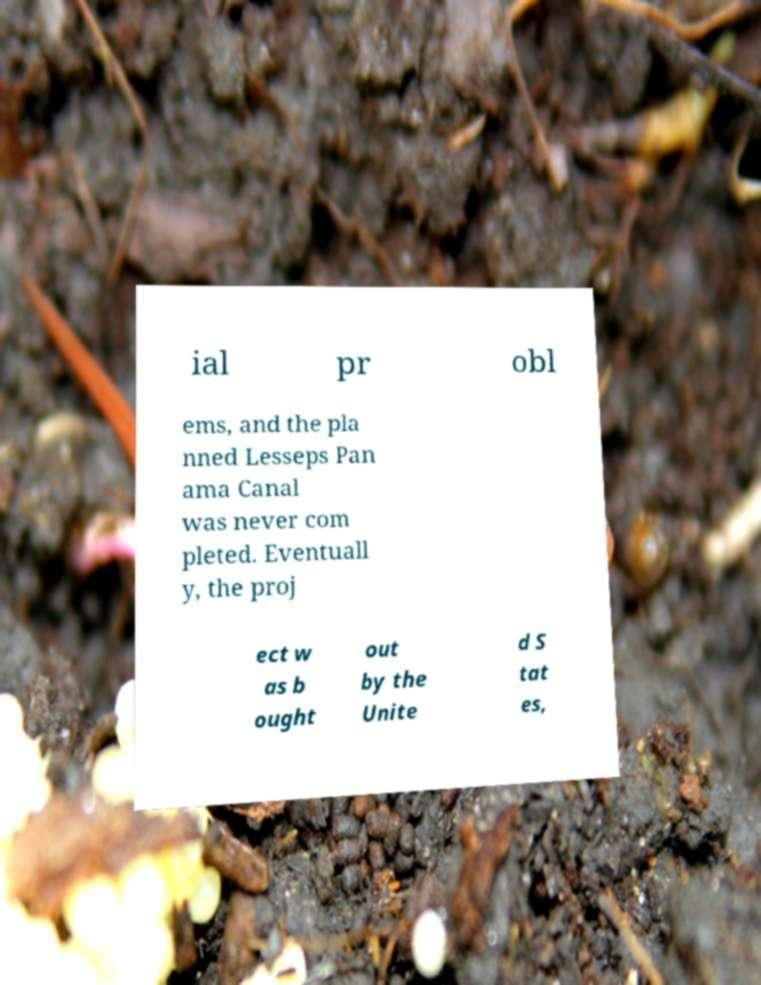What messages or text are displayed in this image? I need them in a readable, typed format. ial pr obl ems, and the pla nned Lesseps Pan ama Canal was never com pleted. Eventuall y, the proj ect w as b ought out by the Unite d S tat es, 